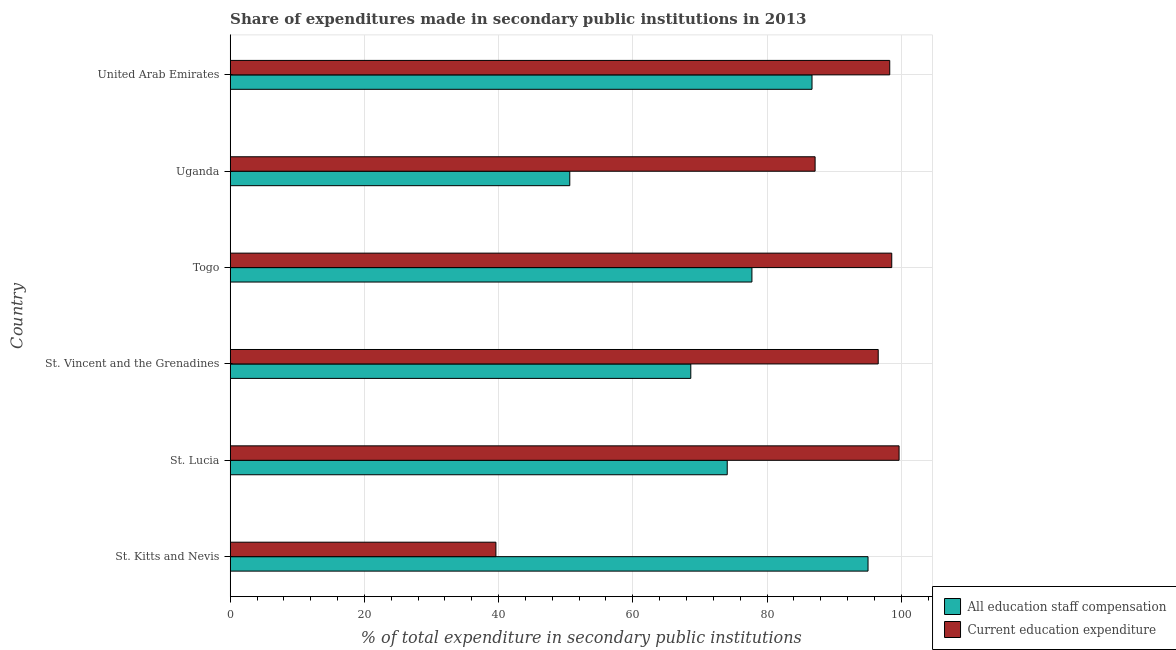How many groups of bars are there?
Provide a succinct answer. 6. Are the number of bars per tick equal to the number of legend labels?
Your answer should be compact. Yes. Are the number of bars on each tick of the Y-axis equal?
Offer a terse response. Yes. What is the label of the 2nd group of bars from the top?
Offer a very short reply. Uganda. In how many cases, is the number of bars for a given country not equal to the number of legend labels?
Offer a very short reply. 0. What is the expenditure in education in Togo?
Keep it short and to the point. 98.58. Across all countries, what is the maximum expenditure in staff compensation?
Keep it short and to the point. 95.05. Across all countries, what is the minimum expenditure in education?
Your answer should be very brief. 39.59. In which country was the expenditure in staff compensation maximum?
Give a very brief answer. St. Kitts and Nevis. In which country was the expenditure in education minimum?
Your response must be concise. St. Kitts and Nevis. What is the total expenditure in staff compensation in the graph?
Provide a succinct answer. 452.8. What is the difference between the expenditure in staff compensation in St. Kitts and Nevis and that in Uganda?
Your response must be concise. 44.44. What is the difference between the expenditure in education in St. Kitts and Nevis and the expenditure in staff compensation in Uganda?
Give a very brief answer. -11.01. What is the average expenditure in education per country?
Offer a very short reply. 86.64. What is the difference between the expenditure in education and expenditure in staff compensation in St. Kitts and Nevis?
Your answer should be compact. -55.45. Is the expenditure in education in St. Kitts and Nevis less than that in St. Vincent and the Grenadines?
Your answer should be compact. Yes. Is the difference between the expenditure in education in Uganda and United Arab Emirates greater than the difference between the expenditure in staff compensation in Uganda and United Arab Emirates?
Give a very brief answer. Yes. What is the difference between the highest and the second highest expenditure in staff compensation?
Keep it short and to the point. 8.35. What is the difference between the highest and the lowest expenditure in staff compensation?
Give a very brief answer. 44.44. Is the sum of the expenditure in staff compensation in Togo and Uganda greater than the maximum expenditure in education across all countries?
Your response must be concise. Yes. What does the 2nd bar from the top in Togo represents?
Offer a terse response. All education staff compensation. What does the 1st bar from the bottom in St. Vincent and the Grenadines represents?
Your response must be concise. All education staff compensation. How many bars are there?
Make the answer very short. 12. How many countries are there in the graph?
Keep it short and to the point. 6. Are the values on the major ticks of X-axis written in scientific E-notation?
Make the answer very short. No. Does the graph contain any zero values?
Ensure brevity in your answer.  No. Does the graph contain grids?
Give a very brief answer. Yes. How many legend labels are there?
Provide a succinct answer. 2. How are the legend labels stacked?
Offer a very short reply. Vertical. What is the title of the graph?
Provide a succinct answer. Share of expenditures made in secondary public institutions in 2013. What is the label or title of the X-axis?
Keep it short and to the point. % of total expenditure in secondary public institutions. What is the label or title of the Y-axis?
Offer a terse response. Country. What is the % of total expenditure in secondary public institutions of All education staff compensation in St. Kitts and Nevis?
Provide a succinct answer. 95.05. What is the % of total expenditure in secondary public institutions in Current education expenditure in St. Kitts and Nevis?
Give a very brief answer. 39.59. What is the % of total expenditure in secondary public institutions in All education staff compensation in St. Lucia?
Give a very brief answer. 74.07. What is the % of total expenditure in secondary public institutions of Current education expenditure in St. Lucia?
Your response must be concise. 99.67. What is the % of total expenditure in secondary public institutions in All education staff compensation in St. Vincent and the Grenadines?
Offer a very short reply. 68.64. What is the % of total expenditure in secondary public institutions in Current education expenditure in St. Vincent and the Grenadines?
Offer a terse response. 96.57. What is the % of total expenditure in secondary public institutions of All education staff compensation in Togo?
Provide a short and direct response. 77.75. What is the % of total expenditure in secondary public institutions in Current education expenditure in Togo?
Ensure brevity in your answer.  98.58. What is the % of total expenditure in secondary public institutions of All education staff compensation in Uganda?
Keep it short and to the point. 50.6. What is the % of total expenditure in secondary public institutions in Current education expenditure in Uganda?
Provide a succinct answer. 87.16. What is the % of total expenditure in secondary public institutions in All education staff compensation in United Arab Emirates?
Provide a short and direct response. 86.7. What is the % of total expenditure in secondary public institutions of Current education expenditure in United Arab Emirates?
Keep it short and to the point. 98.28. Across all countries, what is the maximum % of total expenditure in secondary public institutions in All education staff compensation?
Keep it short and to the point. 95.05. Across all countries, what is the maximum % of total expenditure in secondary public institutions in Current education expenditure?
Provide a succinct answer. 99.67. Across all countries, what is the minimum % of total expenditure in secondary public institutions in All education staff compensation?
Make the answer very short. 50.6. Across all countries, what is the minimum % of total expenditure in secondary public institutions of Current education expenditure?
Make the answer very short. 39.59. What is the total % of total expenditure in secondary public institutions of All education staff compensation in the graph?
Offer a terse response. 452.8. What is the total % of total expenditure in secondary public institutions in Current education expenditure in the graph?
Your answer should be compact. 519.86. What is the difference between the % of total expenditure in secondary public institutions of All education staff compensation in St. Kitts and Nevis and that in St. Lucia?
Make the answer very short. 20.98. What is the difference between the % of total expenditure in secondary public institutions in Current education expenditure in St. Kitts and Nevis and that in St. Lucia?
Keep it short and to the point. -60.08. What is the difference between the % of total expenditure in secondary public institutions in All education staff compensation in St. Kitts and Nevis and that in St. Vincent and the Grenadines?
Give a very brief answer. 26.41. What is the difference between the % of total expenditure in secondary public institutions in Current education expenditure in St. Kitts and Nevis and that in St. Vincent and the Grenadines?
Give a very brief answer. -56.97. What is the difference between the % of total expenditure in secondary public institutions of All education staff compensation in St. Kitts and Nevis and that in Togo?
Ensure brevity in your answer.  17.3. What is the difference between the % of total expenditure in secondary public institutions of Current education expenditure in St. Kitts and Nevis and that in Togo?
Ensure brevity in your answer.  -58.99. What is the difference between the % of total expenditure in secondary public institutions in All education staff compensation in St. Kitts and Nevis and that in Uganda?
Provide a short and direct response. 44.44. What is the difference between the % of total expenditure in secondary public institutions in Current education expenditure in St. Kitts and Nevis and that in Uganda?
Make the answer very short. -47.57. What is the difference between the % of total expenditure in secondary public institutions in All education staff compensation in St. Kitts and Nevis and that in United Arab Emirates?
Provide a short and direct response. 8.35. What is the difference between the % of total expenditure in secondary public institutions of Current education expenditure in St. Kitts and Nevis and that in United Arab Emirates?
Offer a very short reply. -58.69. What is the difference between the % of total expenditure in secondary public institutions in All education staff compensation in St. Lucia and that in St. Vincent and the Grenadines?
Your response must be concise. 5.43. What is the difference between the % of total expenditure in secondary public institutions of Current education expenditure in St. Lucia and that in St. Vincent and the Grenadines?
Make the answer very short. 3.11. What is the difference between the % of total expenditure in secondary public institutions of All education staff compensation in St. Lucia and that in Togo?
Your answer should be compact. -3.68. What is the difference between the % of total expenditure in secondary public institutions of Current education expenditure in St. Lucia and that in Togo?
Ensure brevity in your answer.  1.09. What is the difference between the % of total expenditure in secondary public institutions of All education staff compensation in St. Lucia and that in Uganda?
Provide a short and direct response. 23.46. What is the difference between the % of total expenditure in secondary public institutions of Current education expenditure in St. Lucia and that in Uganda?
Provide a short and direct response. 12.51. What is the difference between the % of total expenditure in secondary public institutions in All education staff compensation in St. Lucia and that in United Arab Emirates?
Make the answer very short. -12.63. What is the difference between the % of total expenditure in secondary public institutions in Current education expenditure in St. Lucia and that in United Arab Emirates?
Your answer should be very brief. 1.39. What is the difference between the % of total expenditure in secondary public institutions of All education staff compensation in St. Vincent and the Grenadines and that in Togo?
Give a very brief answer. -9.11. What is the difference between the % of total expenditure in secondary public institutions of Current education expenditure in St. Vincent and the Grenadines and that in Togo?
Provide a succinct answer. -2.02. What is the difference between the % of total expenditure in secondary public institutions of All education staff compensation in St. Vincent and the Grenadines and that in Uganda?
Offer a very short reply. 18.03. What is the difference between the % of total expenditure in secondary public institutions of Current education expenditure in St. Vincent and the Grenadines and that in Uganda?
Your answer should be compact. 9.4. What is the difference between the % of total expenditure in secondary public institutions in All education staff compensation in St. Vincent and the Grenadines and that in United Arab Emirates?
Make the answer very short. -18.06. What is the difference between the % of total expenditure in secondary public institutions of Current education expenditure in St. Vincent and the Grenadines and that in United Arab Emirates?
Provide a succinct answer. -1.72. What is the difference between the % of total expenditure in secondary public institutions of All education staff compensation in Togo and that in Uganda?
Make the answer very short. 27.14. What is the difference between the % of total expenditure in secondary public institutions of Current education expenditure in Togo and that in Uganda?
Offer a terse response. 11.42. What is the difference between the % of total expenditure in secondary public institutions in All education staff compensation in Togo and that in United Arab Emirates?
Make the answer very short. -8.95. What is the difference between the % of total expenditure in secondary public institutions in Current education expenditure in Togo and that in United Arab Emirates?
Keep it short and to the point. 0.3. What is the difference between the % of total expenditure in secondary public institutions in All education staff compensation in Uganda and that in United Arab Emirates?
Provide a short and direct response. -36.1. What is the difference between the % of total expenditure in secondary public institutions in Current education expenditure in Uganda and that in United Arab Emirates?
Ensure brevity in your answer.  -11.12. What is the difference between the % of total expenditure in secondary public institutions of All education staff compensation in St. Kitts and Nevis and the % of total expenditure in secondary public institutions of Current education expenditure in St. Lucia?
Provide a short and direct response. -4.63. What is the difference between the % of total expenditure in secondary public institutions of All education staff compensation in St. Kitts and Nevis and the % of total expenditure in secondary public institutions of Current education expenditure in St. Vincent and the Grenadines?
Your answer should be compact. -1.52. What is the difference between the % of total expenditure in secondary public institutions in All education staff compensation in St. Kitts and Nevis and the % of total expenditure in secondary public institutions in Current education expenditure in Togo?
Make the answer very short. -3.53. What is the difference between the % of total expenditure in secondary public institutions of All education staff compensation in St. Kitts and Nevis and the % of total expenditure in secondary public institutions of Current education expenditure in Uganda?
Give a very brief answer. 7.89. What is the difference between the % of total expenditure in secondary public institutions of All education staff compensation in St. Kitts and Nevis and the % of total expenditure in secondary public institutions of Current education expenditure in United Arab Emirates?
Ensure brevity in your answer.  -3.23. What is the difference between the % of total expenditure in secondary public institutions in All education staff compensation in St. Lucia and the % of total expenditure in secondary public institutions in Current education expenditure in St. Vincent and the Grenadines?
Make the answer very short. -22.5. What is the difference between the % of total expenditure in secondary public institutions of All education staff compensation in St. Lucia and the % of total expenditure in secondary public institutions of Current education expenditure in Togo?
Your answer should be compact. -24.52. What is the difference between the % of total expenditure in secondary public institutions of All education staff compensation in St. Lucia and the % of total expenditure in secondary public institutions of Current education expenditure in Uganda?
Your answer should be very brief. -13.1. What is the difference between the % of total expenditure in secondary public institutions of All education staff compensation in St. Lucia and the % of total expenditure in secondary public institutions of Current education expenditure in United Arab Emirates?
Ensure brevity in your answer.  -24.22. What is the difference between the % of total expenditure in secondary public institutions of All education staff compensation in St. Vincent and the Grenadines and the % of total expenditure in secondary public institutions of Current education expenditure in Togo?
Keep it short and to the point. -29.94. What is the difference between the % of total expenditure in secondary public institutions of All education staff compensation in St. Vincent and the Grenadines and the % of total expenditure in secondary public institutions of Current education expenditure in Uganda?
Ensure brevity in your answer.  -18.52. What is the difference between the % of total expenditure in secondary public institutions in All education staff compensation in St. Vincent and the Grenadines and the % of total expenditure in secondary public institutions in Current education expenditure in United Arab Emirates?
Offer a very short reply. -29.64. What is the difference between the % of total expenditure in secondary public institutions in All education staff compensation in Togo and the % of total expenditure in secondary public institutions in Current education expenditure in Uganda?
Give a very brief answer. -9.42. What is the difference between the % of total expenditure in secondary public institutions in All education staff compensation in Togo and the % of total expenditure in secondary public institutions in Current education expenditure in United Arab Emirates?
Ensure brevity in your answer.  -20.54. What is the difference between the % of total expenditure in secondary public institutions of All education staff compensation in Uganda and the % of total expenditure in secondary public institutions of Current education expenditure in United Arab Emirates?
Provide a succinct answer. -47.68. What is the average % of total expenditure in secondary public institutions of All education staff compensation per country?
Ensure brevity in your answer.  75.47. What is the average % of total expenditure in secondary public institutions in Current education expenditure per country?
Your answer should be very brief. 86.64. What is the difference between the % of total expenditure in secondary public institutions of All education staff compensation and % of total expenditure in secondary public institutions of Current education expenditure in St. Kitts and Nevis?
Offer a very short reply. 55.45. What is the difference between the % of total expenditure in secondary public institutions in All education staff compensation and % of total expenditure in secondary public institutions in Current education expenditure in St. Lucia?
Your answer should be very brief. -25.61. What is the difference between the % of total expenditure in secondary public institutions of All education staff compensation and % of total expenditure in secondary public institutions of Current education expenditure in St. Vincent and the Grenadines?
Your response must be concise. -27.93. What is the difference between the % of total expenditure in secondary public institutions of All education staff compensation and % of total expenditure in secondary public institutions of Current education expenditure in Togo?
Give a very brief answer. -20.84. What is the difference between the % of total expenditure in secondary public institutions in All education staff compensation and % of total expenditure in secondary public institutions in Current education expenditure in Uganda?
Keep it short and to the point. -36.56. What is the difference between the % of total expenditure in secondary public institutions of All education staff compensation and % of total expenditure in secondary public institutions of Current education expenditure in United Arab Emirates?
Provide a short and direct response. -11.58. What is the ratio of the % of total expenditure in secondary public institutions in All education staff compensation in St. Kitts and Nevis to that in St. Lucia?
Ensure brevity in your answer.  1.28. What is the ratio of the % of total expenditure in secondary public institutions of Current education expenditure in St. Kitts and Nevis to that in St. Lucia?
Keep it short and to the point. 0.4. What is the ratio of the % of total expenditure in secondary public institutions of All education staff compensation in St. Kitts and Nevis to that in St. Vincent and the Grenadines?
Ensure brevity in your answer.  1.38. What is the ratio of the % of total expenditure in secondary public institutions of Current education expenditure in St. Kitts and Nevis to that in St. Vincent and the Grenadines?
Keep it short and to the point. 0.41. What is the ratio of the % of total expenditure in secondary public institutions in All education staff compensation in St. Kitts and Nevis to that in Togo?
Make the answer very short. 1.22. What is the ratio of the % of total expenditure in secondary public institutions of Current education expenditure in St. Kitts and Nevis to that in Togo?
Provide a succinct answer. 0.4. What is the ratio of the % of total expenditure in secondary public institutions of All education staff compensation in St. Kitts and Nevis to that in Uganda?
Provide a succinct answer. 1.88. What is the ratio of the % of total expenditure in secondary public institutions in Current education expenditure in St. Kitts and Nevis to that in Uganda?
Make the answer very short. 0.45. What is the ratio of the % of total expenditure in secondary public institutions of All education staff compensation in St. Kitts and Nevis to that in United Arab Emirates?
Give a very brief answer. 1.1. What is the ratio of the % of total expenditure in secondary public institutions of Current education expenditure in St. Kitts and Nevis to that in United Arab Emirates?
Provide a succinct answer. 0.4. What is the ratio of the % of total expenditure in secondary public institutions in All education staff compensation in St. Lucia to that in St. Vincent and the Grenadines?
Offer a terse response. 1.08. What is the ratio of the % of total expenditure in secondary public institutions in Current education expenditure in St. Lucia to that in St. Vincent and the Grenadines?
Your answer should be very brief. 1.03. What is the ratio of the % of total expenditure in secondary public institutions of All education staff compensation in St. Lucia to that in Togo?
Make the answer very short. 0.95. What is the ratio of the % of total expenditure in secondary public institutions of Current education expenditure in St. Lucia to that in Togo?
Provide a short and direct response. 1.01. What is the ratio of the % of total expenditure in secondary public institutions of All education staff compensation in St. Lucia to that in Uganda?
Your answer should be compact. 1.46. What is the ratio of the % of total expenditure in secondary public institutions in Current education expenditure in St. Lucia to that in Uganda?
Keep it short and to the point. 1.14. What is the ratio of the % of total expenditure in secondary public institutions of All education staff compensation in St. Lucia to that in United Arab Emirates?
Offer a terse response. 0.85. What is the ratio of the % of total expenditure in secondary public institutions of Current education expenditure in St. Lucia to that in United Arab Emirates?
Offer a terse response. 1.01. What is the ratio of the % of total expenditure in secondary public institutions in All education staff compensation in St. Vincent and the Grenadines to that in Togo?
Your answer should be very brief. 0.88. What is the ratio of the % of total expenditure in secondary public institutions in Current education expenditure in St. Vincent and the Grenadines to that in Togo?
Keep it short and to the point. 0.98. What is the ratio of the % of total expenditure in secondary public institutions of All education staff compensation in St. Vincent and the Grenadines to that in Uganda?
Provide a succinct answer. 1.36. What is the ratio of the % of total expenditure in secondary public institutions in Current education expenditure in St. Vincent and the Grenadines to that in Uganda?
Give a very brief answer. 1.11. What is the ratio of the % of total expenditure in secondary public institutions of All education staff compensation in St. Vincent and the Grenadines to that in United Arab Emirates?
Make the answer very short. 0.79. What is the ratio of the % of total expenditure in secondary public institutions in Current education expenditure in St. Vincent and the Grenadines to that in United Arab Emirates?
Provide a short and direct response. 0.98. What is the ratio of the % of total expenditure in secondary public institutions in All education staff compensation in Togo to that in Uganda?
Give a very brief answer. 1.54. What is the ratio of the % of total expenditure in secondary public institutions of Current education expenditure in Togo to that in Uganda?
Ensure brevity in your answer.  1.13. What is the ratio of the % of total expenditure in secondary public institutions of All education staff compensation in Togo to that in United Arab Emirates?
Offer a terse response. 0.9. What is the ratio of the % of total expenditure in secondary public institutions of Current education expenditure in Togo to that in United Arab Emirates?
Keep it short and to the point. 1. What is the ratio of the % of total expenditure in secondary public institutions of All education staff compensation in Uganda to that in United Arab Emirates?
Give a very brief answer. 0.58. What is the ratio of the % of total expenditure in secondary public institutions of Current education expenditure in Uganda to that in United Arab Emirates?
Your answer should be compact. 0.89. What is the difference between the highest and the second highest % of total expenditure in secondary public institutions in All education staff compensation?
Ensure brevity in your answer.  8.35. What is the difference between the highest and the second highest % of total expenditure in secondary public institutions of Current education expenditure?
Give a very brief answer. 1.09. What is the difference between the highest and the lowest % of total expenditure in secondary public institutions in All education staff compensation?
Your answer should be compact. 44.44. What is the difference between the highest and the lowest % of total expenditure in secondary public institutions in Current education expenditure?
Ensure brevity in your answer.  60.08. 